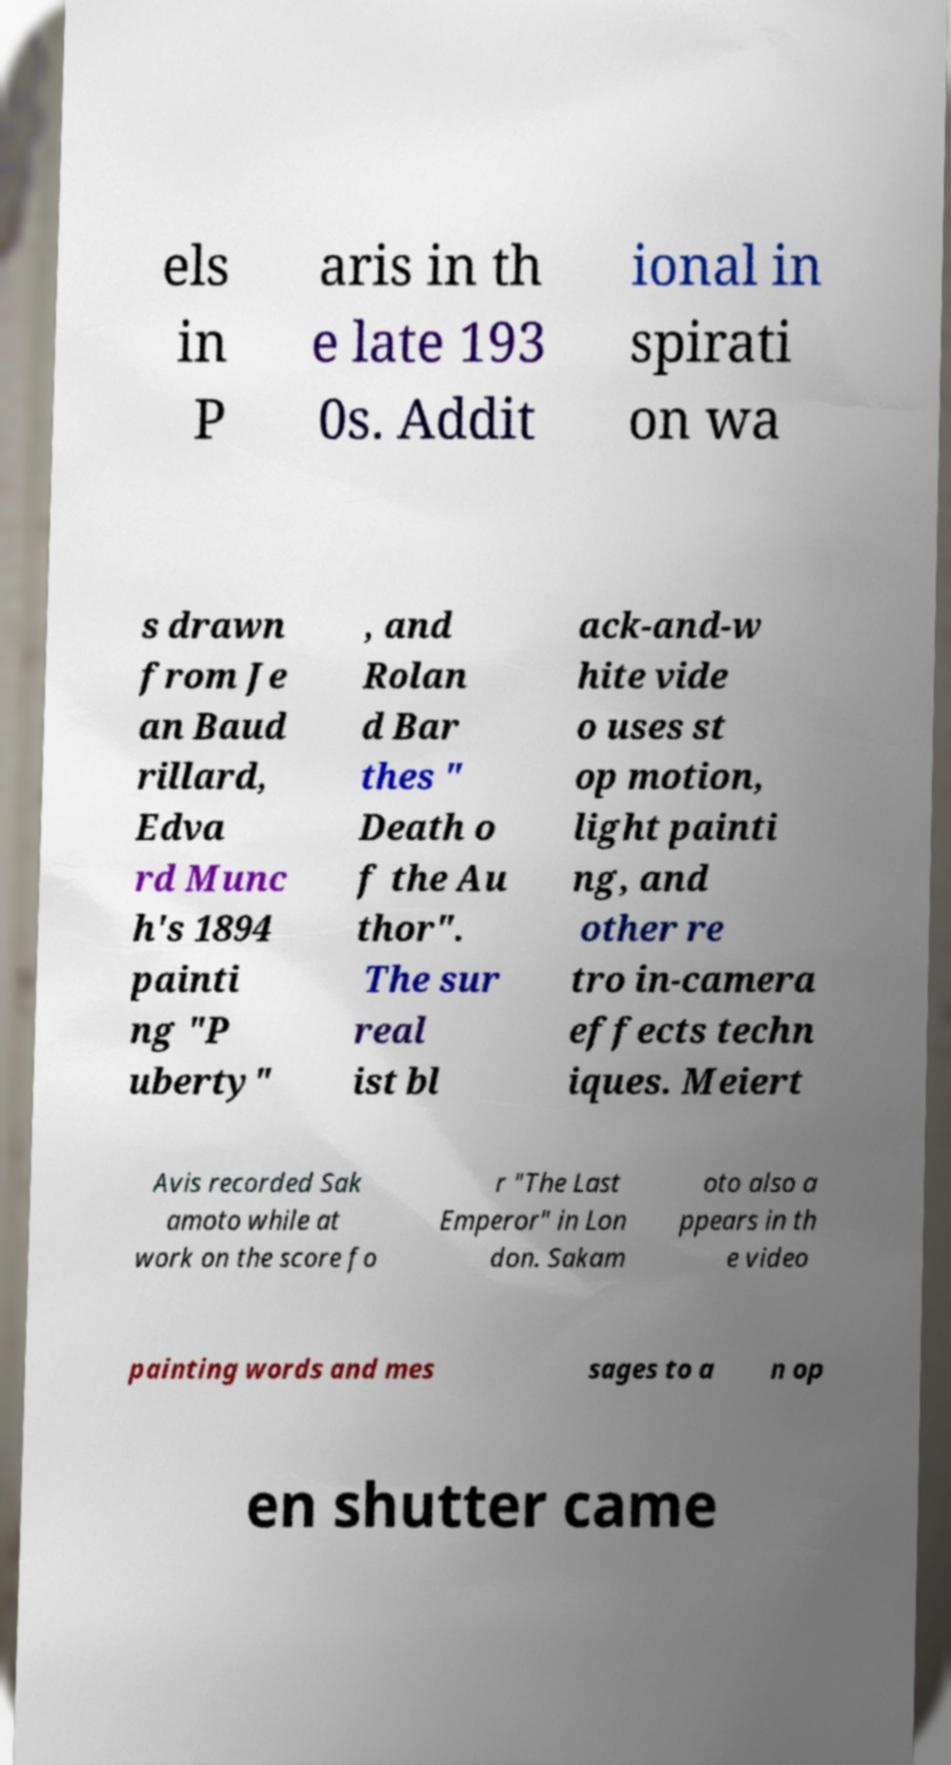Can you read and provide the text displayed in the image?This photo seems to have some interesting text. Can you extract and type it out for me? els in P aris in th e late 193 0s. Addit ional in spirati on wa s drawn from Je an Baud rillard, Edva rd Munc h's 1894 painti ng "P uberty" , and Rolan d Bar thes " Death o f the Au thor". The sur real ist bl ack-and-w hite vide o uses st op motion, light painti ng, and other re tro in-camera effects techn iques. Meiert Avis recorded Sak amoto while at work on the score fo r "The Last Emperor" in Lon don. Sakam oto also a ppears in th e video painting words and mes sages to a n op en shutter came 